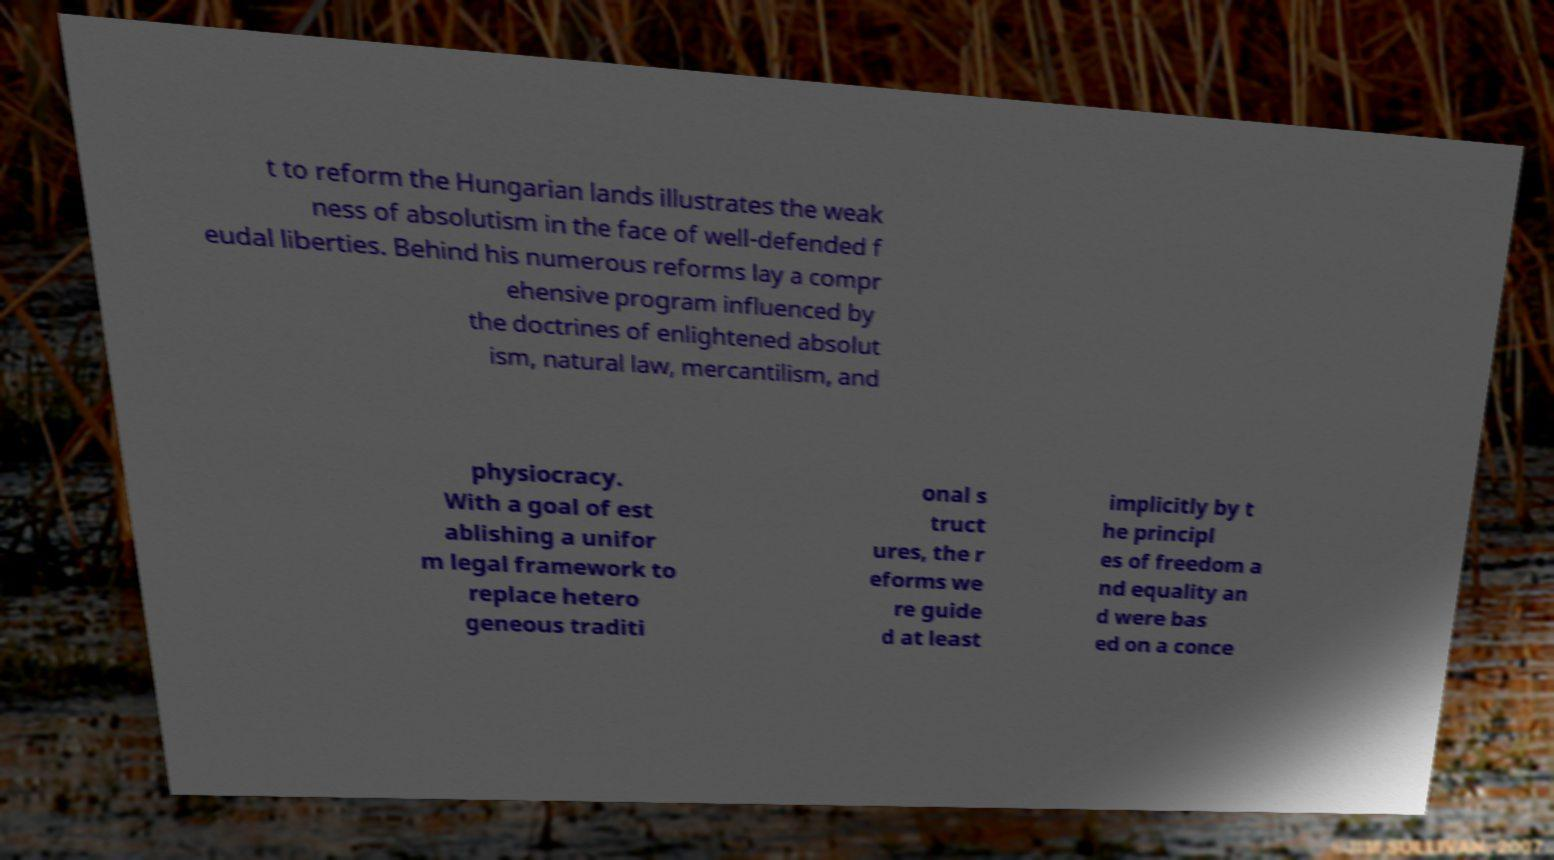For documentation purposes, I need the text within this image transcribed. Could you provide that? t to reform the Hungarian lands illustrates the weak ness of absolutism in the face of well-defended f eudal liberties. Behind his numerous reforms lay a compr ehensive program influenced by the doctrines of enlightened absolut ism, natural law, mercantilism, and physiocracy. With a goal of est ablishing a unifor m legal framework to replace hetero geneous traditi onal s truct ures, the r eforms we re guide d at least implicitly by t he principl es of freedom a nd equality an d were bas ed on a conce 